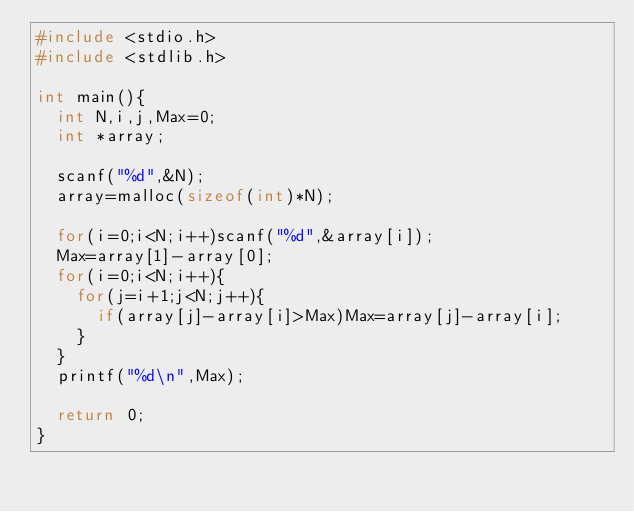<code> <loc_0><loc_0><loc_500><loc_500><_C_>#include <stdio.h>
#include <stdlib.h>

int main(){
  int N,i,j,Max=0;
  int *array;

  scanf("%d",&N);
  array=malloc(sizeof(int)*N);

  for(i=0;i<N;i++)scanf("%d",&array[i]);
  Max=array[1]-array[0];
  for(i=0;i<N;i++){
    for(j=i+1;j<N;j++){
      if(array[j]-array[i]>Max)Max=array[j]-array[i];
    }
  }
  printf("%d\n",Max);

  return 0;
}</code> 